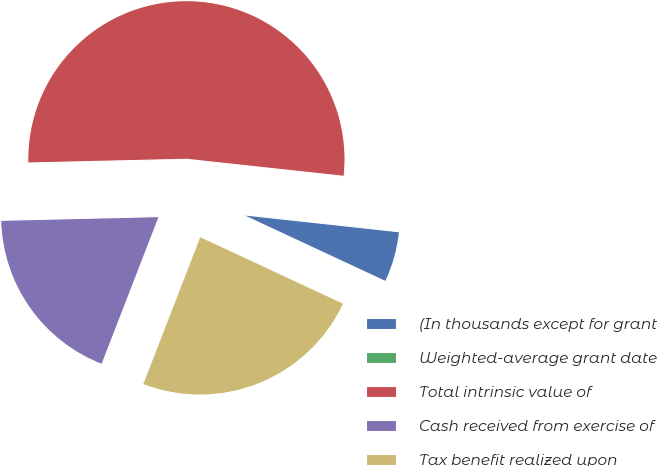Convert chart. <chart><loc_0><loc_0><loc_500><loc_500><pie_chart><fcel>(In thousands except for grant<fcel>Weighted-average grant date<fcel>Total intrinsic value of<fcel>Cash received from exercise of<fcel>Tax benefit realized upon<nl><fcel>5.21%<fcel>0.01%<fcel>52.1%<fcel>18.74%<fcel>23.95%<nl></chart> 